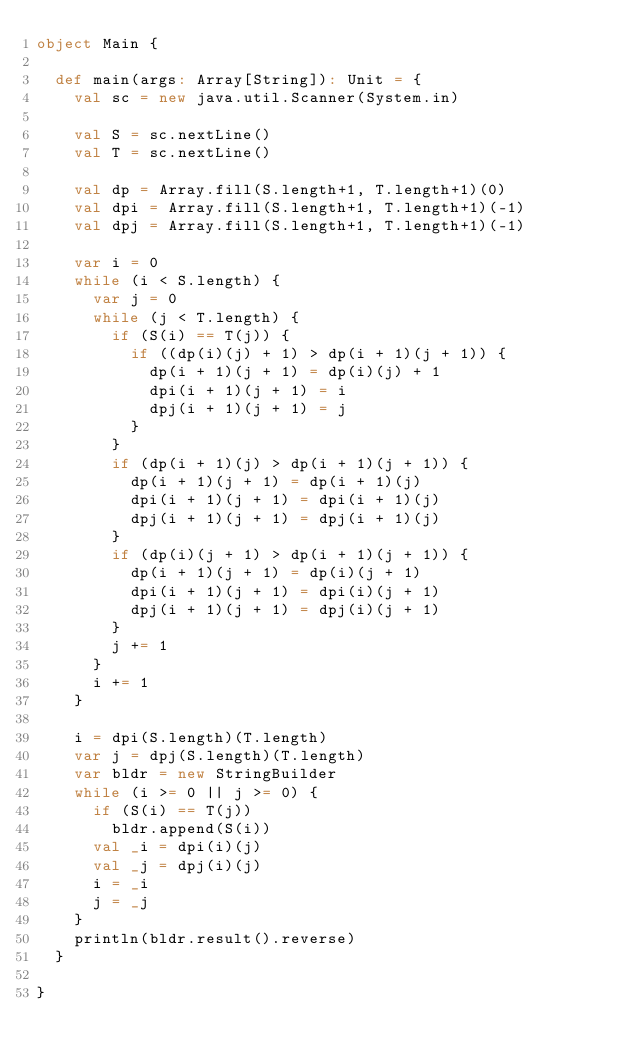Convert code to text. <code><loc_0><loc_0><loc_500><loc_500><_Scala_>object Main {

  def main(args: Array[String]): Unit = {
    val sc = new java.util.Scanner(System.in)

    val S = sc.nextLine()
    val T = sc.nextLine()

    val dp = Array.fill(S.length+1, T.length+1)(0)
    val dpi = Array.fill(S.length+1, T.length+1)(-1)
    val dpj = Array.fill(S.length+1, T.length+1)(-1)

    var i = 0
    while (i < S.length) {
      var j = 0
      while (j < T.length) {
        if (S(i) == T(j)) {
          if ((dp(i)(j) + 1) > dp(i + 1)(j + 1)) {
            dp(i + 1)(j + 1) = dp(i)(j) + 1
            dpi(i + 1)(j + 1) = i
            dpj(i + 1)(j + 1) = j
          }
        }
        if (dp(i + 1)(j) > dp(i + 1)(j + 1)) {
          dp(i + 1)(j + 1) = dp(i + 1)(j)
          dpi(i + 1)(j + 1) = dpi(i + 1)(j)
          dpj(i + 1)(j + 1) = dpj(i + 1)(j)
        }
        if (dp(i)(j + 1) > dp(i + 1)(j + 1)) {
          dp(i + 1)(j + 1) = dp(i)(j + 1)
          dpi(i + 1)(j + 1) = dpi(i)(j + 1)
          dpj(i + 1)(j + 1) = dpj(i)(j + 1)
        }
        j += 1
      }
      i += 1
    }

    i = dpi(S.length)(T.length)
    var j = dpj(S.length)(T.length)
    var bldr = new StringBuilder
    while (i >= 0 || j >= 0) {
      if (S(i) == T(j))
        bldr.append(S(i))
      val _i = dpi(i)(j)
      val _j = dpj(i)(j)
      i = _i
      j = _j
    }
    println(bldr.result().reverse)
  }

}</code> 